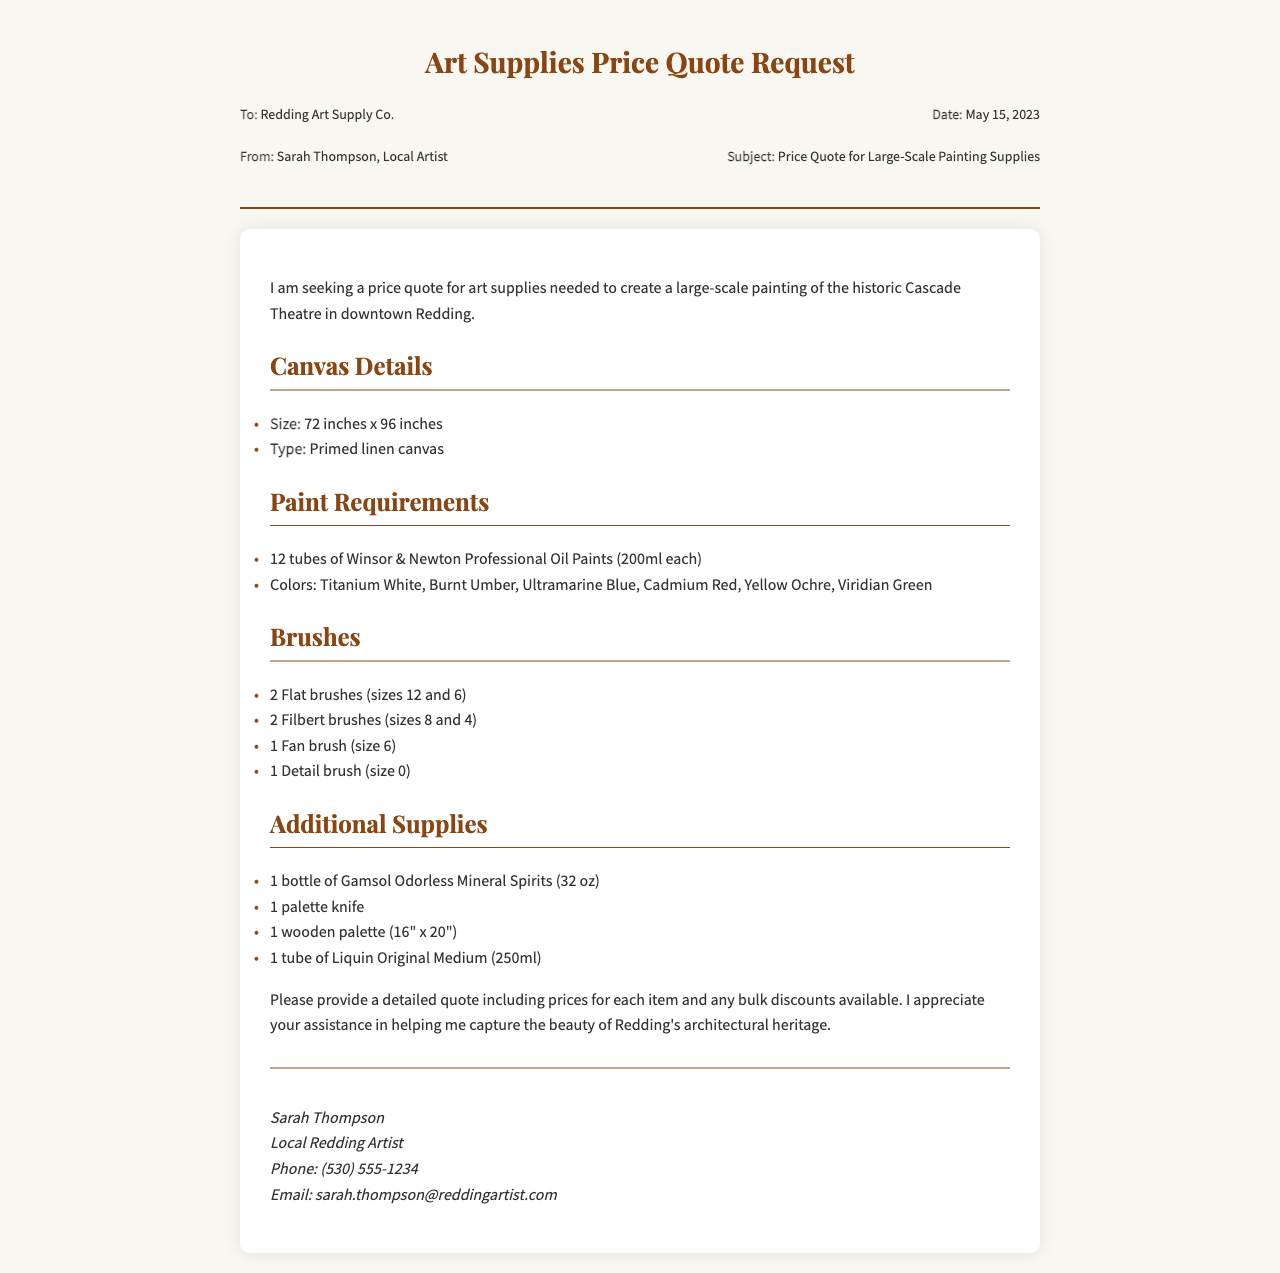What is the subject of the fax? The subject is specifically requested in the document header, indicating what the fax is about.
Answer: Price Quote for Large-Scale Painting Supplies Who is the sender of the fax? The sender's information is included in the document, providing their name and title.
Answer: Sarah Thompson, Local Artist What is the date of the fax? The date is listed in the header section of the document, indicating when the request was made.
Answer: May 15, 2023 What size is the canvas required? The size of the canvas is mentioned in the Canvas Details section, specifying the dimensions needed for the project.
Answer: 72 inches x 96 inches How many tubes of paint are requested? The Paint Requirements section indicates the total number of tubes needed for the artwork.
Answer: 12 tubes What type of brushes are required? The Brushes section lists the types and sizes of brushes requested for the painting.
Answer: Flat, Filbert, Fan, Detail What brand of paint is specified? The Paint Requirements section names the specific brand that the artist wishes to use for the painting.
Answer: Winsor & Newton Professional Oil Paints What additional supplies are needed? The Additional Supplies section enumerates the extra items requested for the project.
Answer: Gamsol Odorless Mineral Spirits, palette knife, wooden palette, Liquin Original Medium Is there a request for bulk discounts? The document mentions a request for pricing details, including potential discounts.
Answer: Yes 